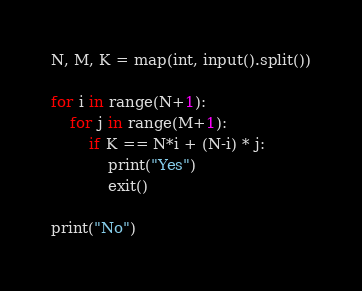<code> <loc_0><loc_0><loc_500><loc_500><_Python_>N, M, K = map(int, input().split())

for i in range(N+1):
    for j in range(M+1):
        if K == N*i + (N-i) * j:
            print("Yes")
            exit()

print("No")
</code> 